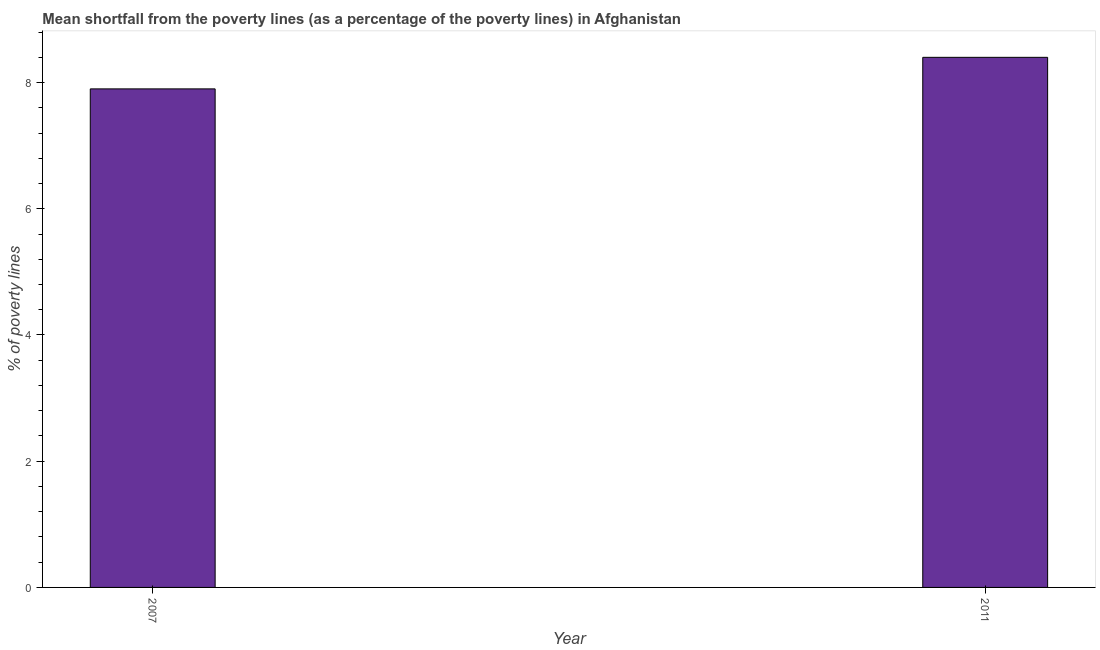What is the title of the graph?
Provide a short and direct response. Mean shortfall from the poverty lines (as a percentage of the poverty lines) in Afghanistan. What is the label or title of the X-axis?
Your answer should be compact. Year. What is the label or title of the Y-axis?
Your answer should be compact. % of poverty lines. Across all years, what is the maximum poverty gap at national poverty lines?
Offer a terse response. 8.4. What is the average poverty gap at national poverty lines per year?
Your answer should be compact. 8.15. What is the median poverty gap at national poverty lines?
Offer a terse response. 8.15. Do a majority of the years between 2011 and 2007 (inclusive) have poverty gap at national poverty lines greater than 4 %?
Keep it short and to the point. No. Is the poverty gap at national poverty lines in 2007 less than that in 2011?
Give a very brief answer. Yes. How many bars are there?
Ensure brevity in your answer.  2. Are all the bars in the graph horizontal?
Your response must be concise. No. What is the difference between two consecutive major ticks on the Y-axis?
Your answer should be very brief. 2. Are the values on the major ticks of Y-axis written in scientific E-notation?
Give a very brief answer. No. What is the % of poverty lines of 2007?
Your answer should be compact. 7.9. What is the difference between the % of poverty lines in 2007 and 2011?
Offer a very short reply. -0.5. 